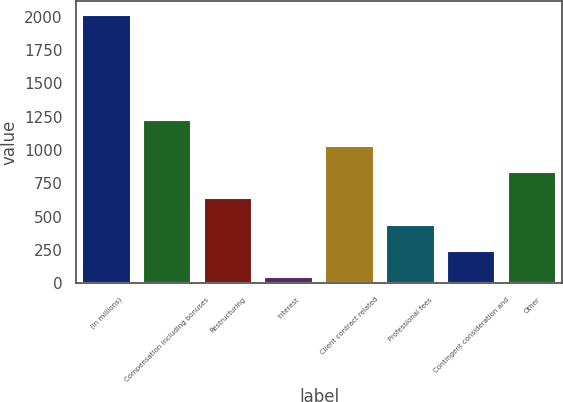Convert chart. <chart><loc_0><loc_0><loc_500><loc_500><bar_chart><fcel>(in millions)<fcel>Compensation including bonuses<fcel>Restructuring<fcel>Interest<fcel>Client contract related<fcel>Professional fees<fcel>Contingent consideration and<fcel>Other<nl><fcel>2017<fcel>1228.2<fcel>636.6<fcel>45<fcel>1031<fcel>439.4<fcel>242.2<fcel>833.8<nl></chart> 